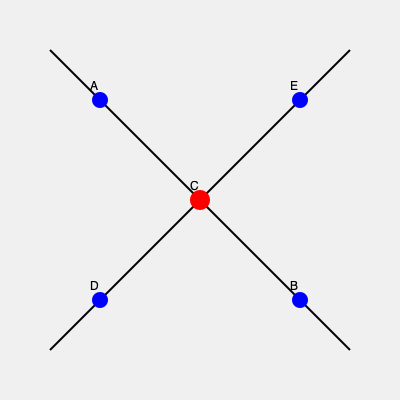Given the map of your school district, where C represents the central administrative office and A, B, D, and E represent schools, which school is geographically farthest from the central office? To determine which school is farthest from the central administrative office, we need to compare the distances between each school and point C. Let's approach this step-by-step:

1. The map is set up on a grid system, with the central office (C) at the center.

2. Schools A, B, D, and E are positioned at the corners of the grid.

3. We can use the concept of diagonal distance to compare the schools' distances from C.

4. Schools A and E are on one diagonal, while schools B and D are on the other diagonal.

5. The schools on the same diagonal are equidistant from C due to the symmetry of the map.

6. However, we can see that the diagonal containing B and D is longer than the one containing A and E.

7. This is because B and D are positioned at opposite corners of the map, creating the maximum possible distance on this grid.

8. Therefore, either B or D is the farthest school from the central office C.

9. Since the question asks for a single answer, we can choose either B or D as they are equidistant from C and both are the farthest.
Answer: B (or D) 